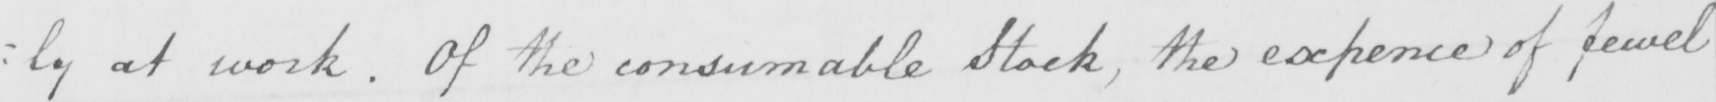What does this handwritten line say? : ly at work . Of the consumable Stock  , the expence of fewel 